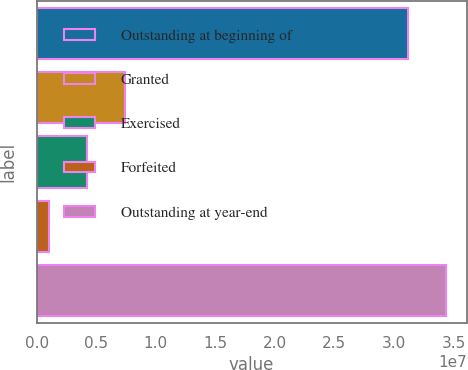<chart> <loc_0><loc_0><loc_500><loc_500><bar_chart><fcel>Outstanding at beginning of<fcel>Granted<fcel>Exercised<fcel>Forfeited<fcel>Outstanding at year-end<nl><fcel>3.12083e+07<fcel>7.39756e+06<fcel>4.21771e+06<fcel>1.03786e+06<fcel>3.43882e+07<nl></chart> 